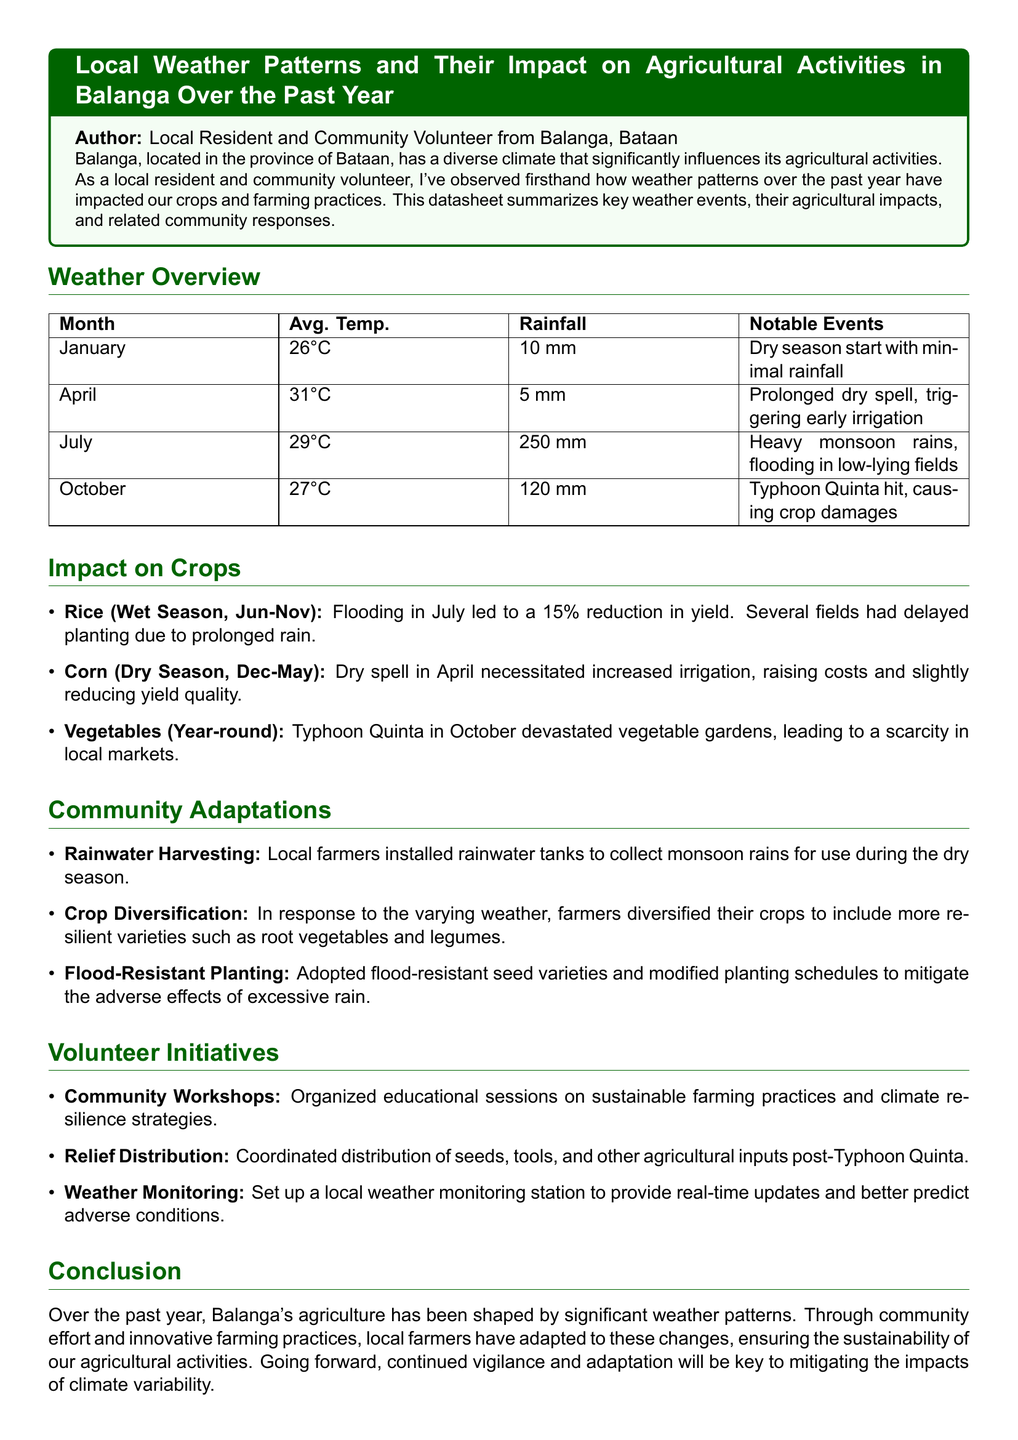what was the average temperature in April? The average temperature in April is stated as 31°C in the document.
Answer: 31°C how much rainfall was recorded in July? The document specifies that July experienced 250 mm of rainfall.
Answer: 250 mm which typhoon hit in October? The document mentions Typhoon Quinta as the notable event in October.
Answer: Typhoon Quinta what percentage reduction in rice yield was caused by flooding? The document indicates a 15% reduction in rice yield due to flooding in July.
Answer: 15% what adaptation method involves installing tanks? The document refers to 'Rainwater Harvesting' as the adaptation method that involves installing tanks.
Answer: Rainwater Harvesting how did the community respond to Typhoon Quinta? The document states that relief distribution was coordinated to provide seeds, tools, and other agricultural inputs.
Answer: Relief Distribution what crop was particularly affected due to Typhoon Quinta? According to the document, vegetable gardens were devastated by Typhoon Quinta.
Answer: Vegetable gardens which agricultural practice was organized through community workshops? The workshops focused on sustainable farming practices and climate resilience strategies as mentioned in the document.
Answer: Sustainable farming practices how did farmers respond to the prolonged dry spell in April? The document notes that farmers increased irrigation due to the prolonged dry spell in April.
Answer: Increased irrigation 